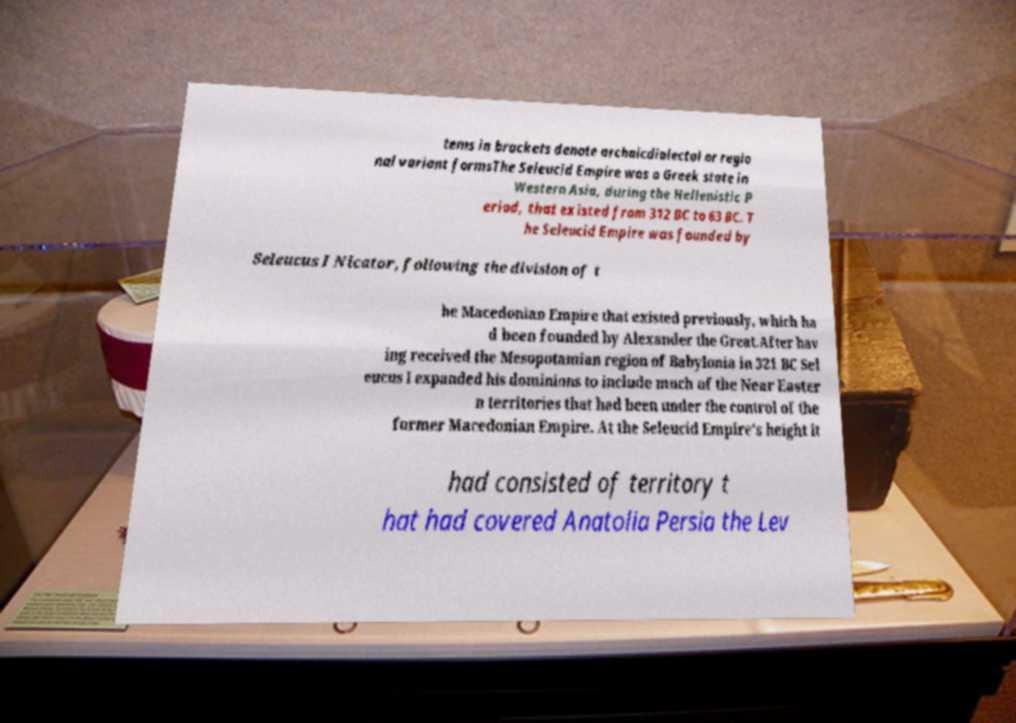Can you accurately transcribe the text from the provided image for me? tems in brackets denote archaicdialectal or regio nal variant formsThe Seleucid Empire was a Greek state in Western Asia, during the Hellenistic P eriod, that existed from 312 BC to 63 BC. T he Seleucid Empire was founded by Seleucus I Nicator, following the division of t he Macedonian Empire that existed previously, which ha d been founded by Alexander the Great.After hav ing received the Mesopotamian region of Babylonia in 321 BC Sel eucus I expanded his dominions to include much of the Near Easter n territories that had been under the control of the former Macedonian Empire. At the Seleucid Empire's height it had consisted of territory t hat had covered Anatolia Persia the Lev 